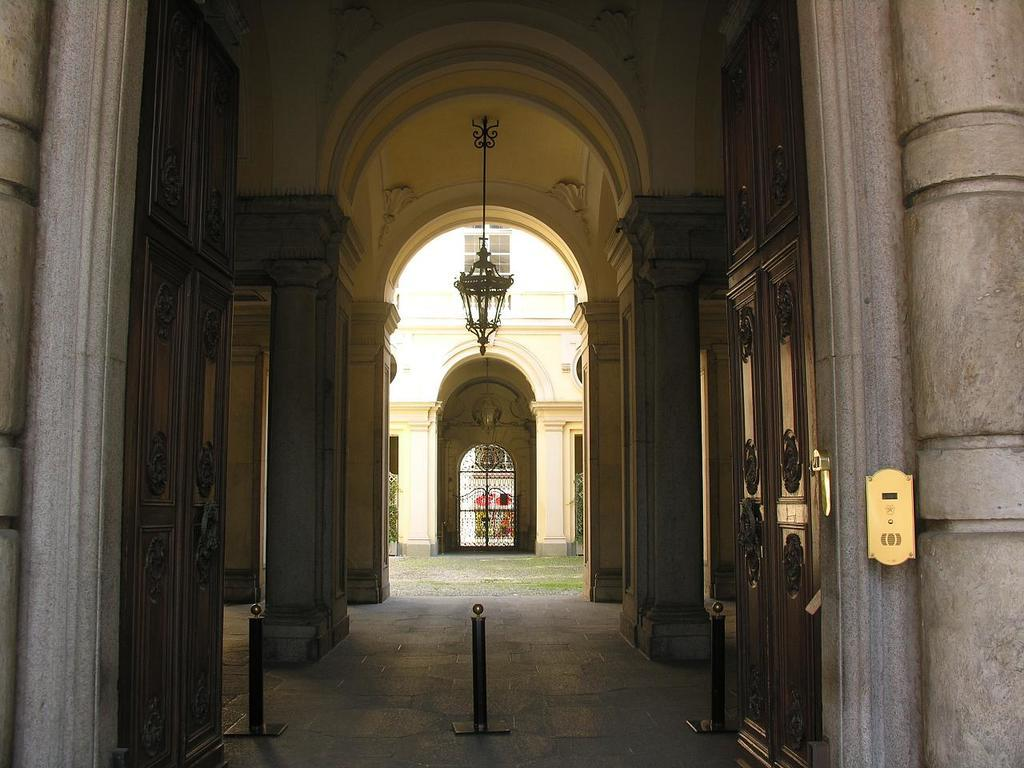What is the main structure visible in the image? There is an entrance gate in the image. Can you describe any specific features of the entrance gate? There is an object hanging from the seal of the entrance gate. What type of invention is being used to join the stomach in the image? There is no stomach or invention present in the image; it only features an entrance gate with an object hanging from the seal. 